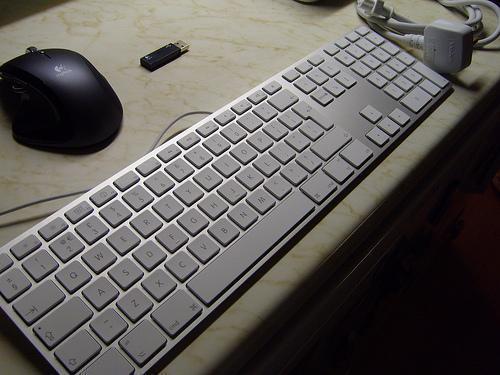How many keyboards are there?
Give a very brief answer. 1. 